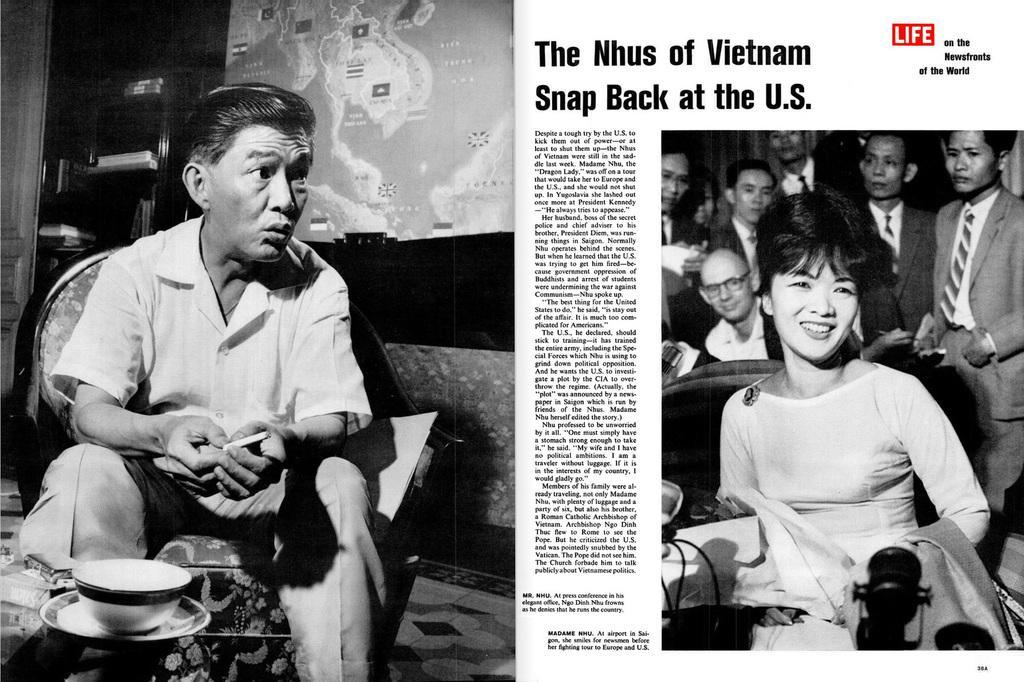Please provide a concise description of this image. This is an edited image. On the left we can see the picture of a person holding some object and sitting on the chair and we can see there are some objects placed on the top of the table. On the right we can see a woman seems to be sitting. In the background we can see the group of persons wearing suits and standing and we can see the poster on which some pictures are printed and there are many number of objects in the background and we can see the text on the image. 